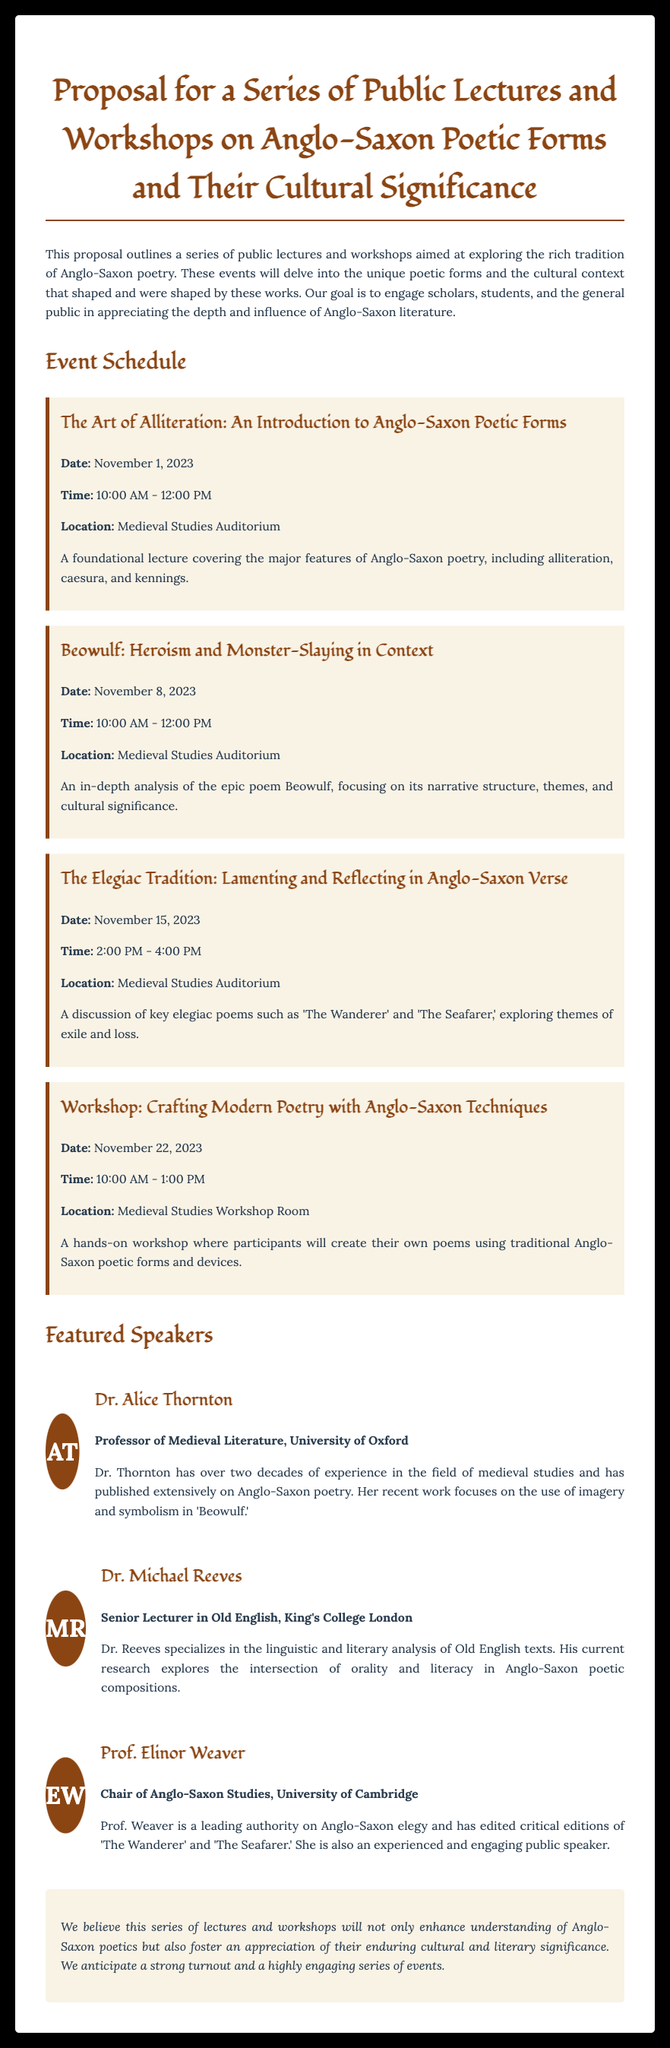What is the title of the proposal? The title of the proposal is stated clearly at the beginning of the document.
Answer: Proposal for a Series of Public Lectures and Workshops on Anglo-Saxon Poetic Forms and Their Cultural Significance Who is the speaker for the workshop on November 22, 2023? The workshop has no specific speaker listed, but featured speakers' names are detailed elsewhere in the document.
Answer: Not specified On what date is the lecture about Beowulf scheduled? The date for the Beowulf lecture is mentioned in the event schedule section.
Answer: November 8, 2023 What is the location for the majority of the events? The location for the events is provided in the schedule section.
Answer: Medieval Studies Auditorium How long is the workshop scheduled for on November 22, 2023? The duration of the workshop is indicated in the event details.
Answer: 3 hours Which university is Dr. Michael Reeves affiliated with? Dr. Michael Reeves' affiliation is mentioned in the speaker biographies section.
Answer: King's College London What is the focus of Prof. Elinor Weaver's research? Prof. Elinor Weaver's expertise is summarized in her biography, highlighting her research focus.
Answer: Anglo-Saxon elegy Which poetic technique is highlighted in the first lecture? The specific poetic technique covered in the first lecture is detailed in the event description.
Answer: Alliteration 